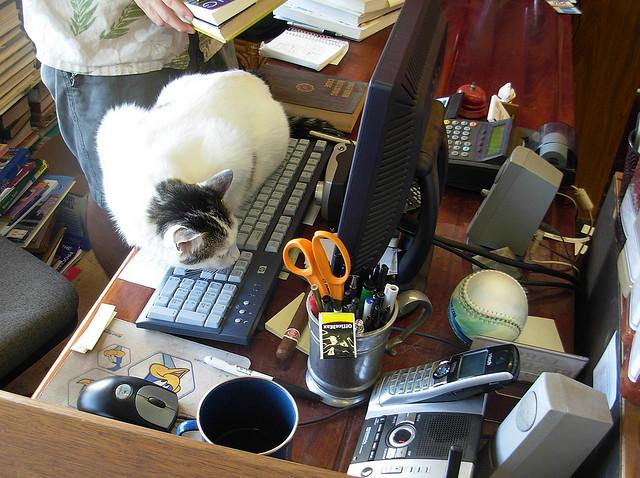What type tobacco product will the person who sits here smoke? cigar 